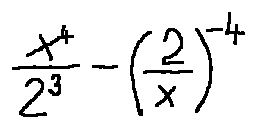<formula> <loc_0><loc_0><loc_500><loc_500>\frac { x ^ { 4 } } { 2 ^ { 3 } } - ( \frac { 2 } { x } ) ^ { - 4 }</formula> 